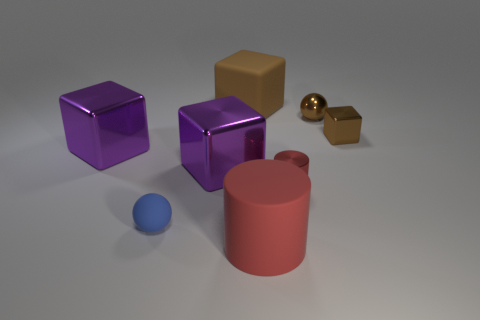What could be the purpose of these objects? The objects seem to be variations of simple 3D shapes, typically used for educational purposes or as props in visualization and rendering practices. The cubes and the cylinder could serve as teaching tools for geometry, while the sheen and reflection on the cubes could be used to study light and materials in art or computer graphics. The sphere might be a simple toy or a geometric subject to showcase different textures or colors. 